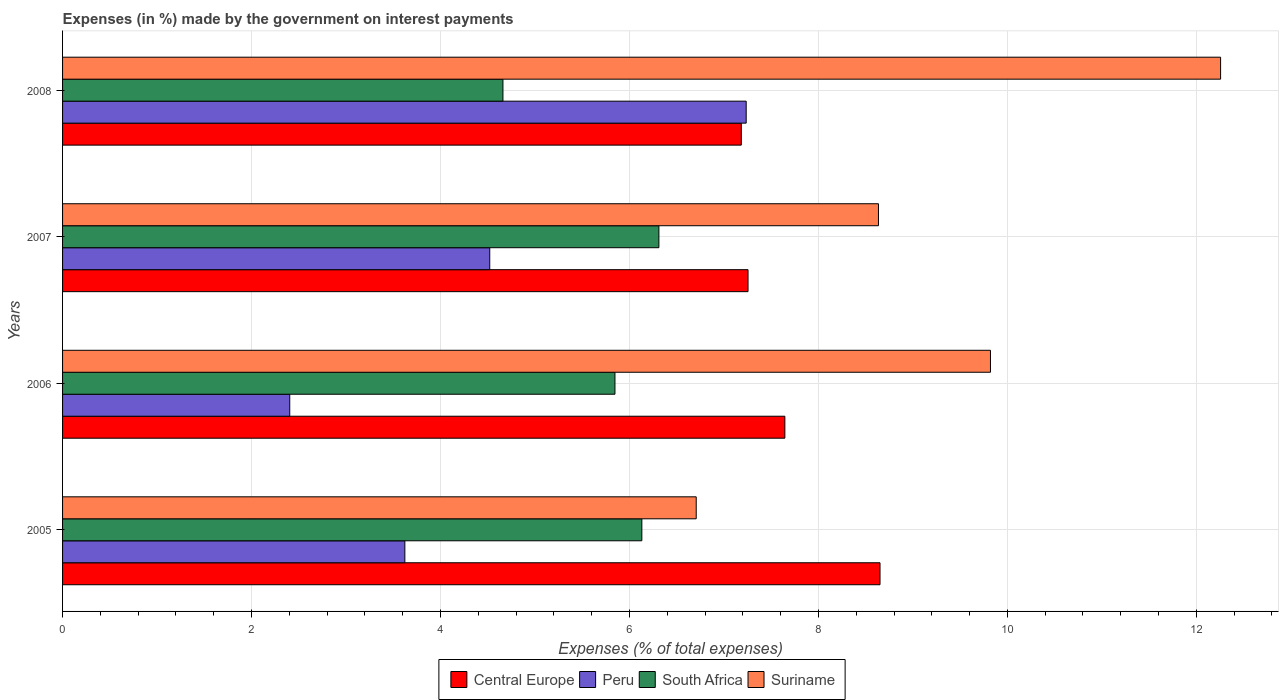How many bars are there on the 4th tick from the top?
Your answer should be compact. 4. In how many cases, is the number of bars for a given year not equal to the number of legend labels?
Your response must be concise. 0. What is the percentage of expenses made by the government on interest payments in South Africa in 2006?
Your answer should be very brief. 5.85. Across all years, what is the maximum percentage of expenses made by the government on interest payments in Central Europe?
Ensure brevity in your answer.  8.65. Across all years, what is the minimum percentage of expenses made by the government on interest payments in Peru?
Offer a terse response. 2.4. In which year was the percentage of expenses made by the government on interest payments in Peru minimum?
Ensure brevity in your answer.  2006. What is the total percentage of expenses made by the government on interest payments in Suriname in the graph?
Keep it short and to the point. 37.42. What is the difference between the percentage of expenses made by the government on interest payments in Central Europe in 2007 and that in 2008?
Ensure brevity in your answer.  0.07. What is the difference between the percentage of expenses made by the government on interest payments in Central Europe in 2008 and the percentage of expenses made by the government on interest payments in Suriname in 2007?
Offer a terse response. -1.45. What is the average percentage of expenses made by the government on interest payments in Suriname per year?
Your answer should be compact. 9.36. In the year 2007, what is the difference between the percentage of expenses made by the government on interest payments in Suriname and percentage of expenses made by the government on interest payments in South Africa?
Provide a succinct answer. 2.32. What is the ratio of the percentage of expenses made by the government on interest payments in South Africa in 2006 to that in 2008?
Your answer should be very brief. 1.25. Is the percentage of expenses made by the government on interest payments in South Africa in 2005 less than that in 2006?
Your response must be concise. No. Is the difference between the percentage of expenses made by the government on interest payments in Suriname in 2006 and 2008 greater than the difference between the percentage of expenses made by the government on interest payments in South Africa in 2006 and 2008?
Keep it short and to the point. No. What is the difference between the highest and the second highest percentage of expenses made by the government on interest payments in South Africa?
Your answer should be compact. 0.18. What is the difference between the highest and the lowest percentage of expenses made by the government on interest payments in Central Europe?
Your answer should be very brief. 1.47. Is the sum of the percentage of expenses made by the government on interest payments in Peru in 2006 and 2007 greater than the maximum percentage of expenses made by the government on interest payments in Central Europe across all years?
Offer a very short reply. No. Is it the case that in every year, the sum of the percentage of expenses made by the government on interest payments in Suriname and percentage of expenses made by the government on interest payments in South Africa is greater than the sum of percentage of expenses made by the government on interest payments in Central Europe and percentage of expenses made by the government on interest payments in Peru?
Provide a succinct answer. Yes. What does the 1st bar from the top in 2006 represents?
Your answer should be very brief. Suriname. Is it the case that in every year, the sum of the percentage of expenses made by the government on interest payments in Peru and percentage of expenses made by the government on interest payments in Suriname is greater than the percentage of expenses made by the government on interest payments in South Africa?
Your answer should be very brief. Yes. How many bars are there?
Ensure brevity in your answer.  16. What is the title of the graph?
Offer a very short reply. Expenses (in %) made by the government on interest payments. Does "San Marino" appear as one of the legend labels in the graph?
Make the answer very short. No. What is the label or title of the X-axis?
Make the answer very short. Expenses (% of total expenses). What is the label or title of the Y-axis?
Make the answer very short. Years. What is the Expenses (% of total expenses) of Central Europe in 2005?
Provide a short and direct response. 8.65. What is the Expenses (% of total expenses) of Peru in 2005?
Your response must be concise. 3.62. What is the Expenses (% of total expenses) of South Africa in 2005?
Give a very brief answer. 6.13. What is the Expenses (% of total expenses) of Suriname in 2005?
Offer a very short reply. 6.71. What is the Expenses (% of total expenses) of Central Europe in 2006?
Make the answer very short. 7.64. What is the Expenses (% of total expenses) in Peru in 2006?
Provide a short and direct response. 2.4. What is the Expenses (% of total expenses) in South Africa in 2006?
Keep it short and to the point. 5.85. What is the Expenses (% of total expenses) of Suriname in 2006?
Your response must be concise. 9.82. What is the Expenses (% of total expenses) of Central Europe in 2007?
Your answer should be compact. 7.26. What is the Expenses (% of total expenses) of Peru in 2007?
Offer a terse response. 4.52. What is the Expenses (% of total expenses) of South Africa in 2007?
Your answer should be very brief. 6.31. What is the Expenses (% of total expenses) in Suriname in 2007?
Keep it short and to the point. 8.64. What is the Expenses (% of total expenses) in Central Europe in 2008?
Give a very brief answer. 7.18. What is the Expenses (% of total expenses) in Peru in 2008?
Offer a very short reply. 7.24. What is the Expenses (% of total expenses) in South Africa in 2008?
Provide a succinct answer. 4.66. What is the Expenses (% of total expenses) of Suriname in 2008?
Keep it short and to the point. 12.26. Across all years, what is the maximum Expenses (% of total expenses) in Central Europe?
Ensure brevity in your answer.  8.65. Across all years, what is the maximum Expenses (% of total expenses) in Peru?
Offer a very short reply. 7.24. Across all years, what is the maximum Expenses (% of total expenses) of South Africa?
Provide a succinct answer. 6.31. Across all years, what is the maximum Expenses (% of total expenses) of Suriname?
Your answer should be compact. 12.26. Across all years, what is the minimum Expenses (% of total expenses) in Central Europe?
Ensure brevity in your answer.  7.18. Across all years, what is the minimum Expenses (% of total expenses) in Peru?
Provide a succinct answer. 2.4. Across all years, what is the minimum Expenses (% of total expenses) of South Africa?
Your answer should be compact. 4.66. Across all years, what is the minimum Expenses (% of total expenses) in Suriname?
Provide a succinct answer. 6.71. What is the total Expenses (% of total expenses) of Central Europe in the graph?
Provide a short and direct response. 30.74. What is the total Expenses (% of total expenses) in Peru in the graph?
Provide a succinct answer. 17.78. What is the total Expenses (% of total expenses) of South Africa in the graph?
Offer a very short reply. 22.95. What is the total Expenses (% of total expenses) in Suriname in the graph?
Provide a short and direct response. 37.42. What is the difference between the Expenses (% of total expenses) of Central Europe in 2005 and that in 2006?
Make the answer very short. 1.01. What is the difference between the Expenses (% of total expenses) of Peru in 2005 and that in 2006?
Your answer should be very brief. 1.22. What is the difference between the Expenses (% of total expenses) of South Africa in 2005 and that in 2006?
Provide a succinct answer. 0.28. What is the difference between the Expenses (% of total expenses) of Suriname in 2005 and that in 2006?
Provide a succinct answer. -3.11. What is the difference between the Expenses (% of total expenses) in Central Europe in 2005 and that in 2007?
Offer a very short reply. 1.4. What is the difference between the Expenses (% of total expenses) in Peru in 2005 and that in 2007?
Provide a succinct answer. -0.9. What is the difference between the Expenses (% of total expenses) of South Africa in 2005 and that in 2007?
Offer a terse response. -0.18. What is the difference between the Expenses (% of total expenses) of Suriname in 2005 and that in 2007?
Keep it short and to the point. -1.93. What is the difference between the Expenses (% of total expenses) in Central Europe in 2005 and that in 2008?
Offer a very short reply. 1.47. What is the difference between the Expenses (% of total expenses) in Peru in 2005 and that in 2008?
Offer a very short reply. -3.61. What is the difference between the Expenses (% of total expenses) in South Africa in 2005 and that in 2008?
Keep it short and to the point. 1.47. What is the difference between the Expenses (% of total expenses) in Suriname in 2005 and that in 2008?
Make the answer very short. -5.55. What is the difference between the Expenses (% of total expenses) of Central Europe in 2006 and that in 2007?
Ensure brevity in your answer.  0.39. What is the difference between the Expenses (% of total expenses) in Peru in 2006 and that in 2007?
Your answer should be compact. -2.12. What is the difference between the Expenses (% of total expenses) in South Africa in 2006 and that in 2007?
Ensure brevity in your answer.  -0.47. What is the difference between the Expenses (% of total expenses) in Suriname in 2006 and that in 2007?
Ensure brevity in your answer.  1.19. What is the difference between the Expenses (% of total expenses) of Central Europe in 2006 and that in 2008?
Keep it short and to the point. 0.46. What is the difference between the Expenses (% of total expenses) in Peru in 2006 and that in 2008?
Make the answer very short. -4.83. What is the difference between the Expenses (% of total expenses) in South Africa in 2006 and that in 2008?
Provide a succinct answer. 1.19. What is the difference between the Expenses (% of total expenses) of Suriname in 2006 and that in 2008?
Your answer should be compact. -2.44. What is the difference between the Expenses (% of total expenses) of Central Europe in 2007 and that in 2008?
Provide a succinct answer. 0.07. What is the difference between the Expenses (% of total expenses) in Peru in 2007 and that in 2008?
Make the answer very short. -2.71. What is the difference between the Expenses (% of total expenses) of South Africa in 2007 and that in 2008?
Your response must be concise. 1.65. What is the difference between the Expenses (% of total expenses) in Suriname in 2007 and that in 2008?
Provide a succinct answer. -3.62. What is the difference between the Expenses (% of total expenses) of Central Europe in 2005 and the Expenses (% of total expenses) of Peru in 2006?
Offer a very short reply. 6.25. What is the difference between the Expenses (% of total expenses) of Central Europe in 2005 and the Expenses (% of total expenses) of South Africa in 2006?
Make the answer very short. 2.81. What is the difference between the Expenses (% of total expenses) in Central Europe in 2005 and the Expenses (% of total expenses) in Suriname in 2006?
Give a very brief answer. -1.17. What is the difference between the Expenses (% of total expenses) of Peru in 2005 and the Expenses (% of total expenses) of South Africa in 2006?
Provide a succinct answer. -2.22. What is the difference between the Expenses (% of total expenses) in Peru in 2005 and the Expenses (% of total expenses) in Suriname in 2006?
Your answer should be very brief. -6.2. What is the difference between the Expenses (% of total expenses) of South Africa in 2005 and the Expenses (% of total expenses) of Suriname in 2006?
Your response must be concise. -3.69. What is the difference between the Expenses (% of total expenses) in Central Europe in 2005 and the Expenses (% of total expenses) in Peru in 2007?
Provide a succinct answer. 4.13. What is the difference between the Expenses (% of total expenses) in Central Europe in 2005 and the Expenses (% of total expenses) in South Africa in 2007?
Give a very brief answer. 2.34. What is the difference between the Expenses (% of total expenses) in Central Europe in 2005 and the Expenses (% of total expenses) in Suriname in 2007?
Provide a succinct answer. 0.02. What is the difference between the Expenses (% of total expenses) of Peru in 2005 and the Expenses (% of total expenses) of South Africa in 2007?
Ensure brevity in your answer.  -2.69. What is the difference between the Expenses (% of total expenses) in Peru in 2005 and the Expenses (% of total expenses) in Suriname in 2007?
Provide a short and direct response. -5.01. What is the difference between the Expenses (% of total expenses) of South Africa in 2005 and the Expenses (% of total expenses) of Suriname in 2007?
Provide a succinct answer. -2.5. What is the difference between the Expenses (% of total expenses) in Central Europe in 2005 and the Expenses (% of total expenses) in Peru in 2008?
Provide a short and direct response. 1.42. What is the difference between the Expenses (% of total expenses) in Central Europe in 2005 and the Expenses (% of total expenses) in South Africa in 2008?
Make the answer very short. 3.99. What is the difference between the Expenses (% of total expenses) in Central Europe in 2005 and the Expenses (% of total expenses) in Suriname in 2008?
Keep it short and to the point. -3.6. What is the difference between the Expenses (% of total expenses) in Peru in 2005 and the Expenses (% of total expenses) in South Africa in 2008?
Offer a very short reply. -1.04. What is the difference between the Expenses (% of total expenses) of Peru in 2005 and the Expenses (% of total expenses) of Suriname in 2008?
Your answer should be very brief. -8.63. What is the difference between the Expenses (% of total expenses) of South Africa in 2005 and the Expenses (% of total expenses) of Suriname in 2008?
Provide a short and direct response. -6.13. What is the difference between the Expenses (% of total expenses) in Central Europe in 2006 and the Expenses (% of total expenses) in Peru in 2007?
Offer a very short reply. 3.12. What is the difference between the Expenses (% of total expenses) in Central Europe in 2006 and the Expenses (% of total expenses) in South Africa in 2007?
Ensure brevity in your answer.  1.33. What is the difference between the Expenses (% of total expenses) in Central Europe in 2006 and the Expenses (% of total expenses) in Suriname in 2007?
Ensure brevity in your answer.  -0.99. What is the difference between the Expenses (% of total expenses) of Peru in 2006 and the Expenses (% of total expenses) of South Africa in 2007?
Offer a very short reply. -3.91. What is the difference between the Expenses (% of total expenses) of Peru in 2006 and the Expenses (% of total expenses) of Suriname in 2007?
Offer a terse response. -6.23. What is the difference between the Expenses (% of total expenses) in South Africa in 2006 and the Expenses (% of total expenses) in Suriname in 2007?
Your response must be concise. -2.79. What is the difference between the Expenses (% of total expenses) in Central Europe in 2006 and the Expenses (% of total expenses) in Peru in 2008?
Offer a terse response. 0.41. What is the difference between the Expenses (% of total expenses) of Central Europe in 2006 and the Expenses (% of total expenses) of South Africa in 2008?
Make the answer very short. 2.98. What is the difference between the Expenses (% of total expenses) of Central Europe in 2006 and the Expenses (% of total expenses) of Suriname in 2008?
Provide a short and direct response. -4.61. What is the difference between the Expenses (% of total expenses) in Peru in 2006 and the Expenses (% of total expenses) in South Africa in 2008?
Offer a very short reply. -2.26. What is the difference between the Expenses (% of total expenses) in Peru in 2006 and the Expenses (% of total expenses) in Suriname in 2008?
Provide a succinct answer. -9.85. What is the difference between the Expenses (% of total expenses) in South Africa in 2006 and the Expenses (% of total expenses) in Suriname in 2008?
Your response must be concise. -6.41. What is the difference between the Expenses (% of total expenses) in Central Europe in 2007 and the Expenses (% of total expenses) in Peru in 2008?
Make the answer very short. 0.02. What is the difference between the Expenses (% of total expenses) in Central Europe in 2007 and the Expenses (% of total expenses) in South Africa in 2008?
Offer a terse response. 2.59. What is the difference between the Expenses (% of total expenses) in Central Europe in 2007 and the Expenses (% of total expenses) in Suriname in 2008?
Your response must be concise. -5. What is the difference between the Expenses (% of total expenses) in Peru in 2007 and the Expenses (% of total expenses) in South Africa in 2008?
Provide a short and direct response. -0.14. What is the difference between the Expenses (% of total expenses) in Peru in 2007 and the Expenses (% of total expenses) in Suriname in 2008?
Your response must be concise. -7.74. What is the difference between the Expenses (% of total expenses) in South Africa in 2007 and the Expenses (% of total expenses) in Suriname in 2008?
Keep it short and to the point. -5.95. What is the average Expenses (% of total expenses) in Central Europe per year?
Make the answer very short. 7.68. What is the average Expenses (% of total expenses) of Peru per year?
Keep it short and to the point. 4.45. What is the average Expenses (% of total expenses) in South Africa per year?
Keep it short and to the point. 5.74. What is the average Expenses (% of total expenses) in Suriname per year?
Offer a very short reply. 9.36. In the year 2005, what is the difference between the Expenses (% of total expenses) in Central Europe and Expenses (% of total expenses) in Peru?
Offer a very short reply. 5.03. In the year 2005, what is the difference between the Expenses (% of total expenses) in Central Europe and Expenses (% of total expenses) in South Africa?
Offer a very short reply. 2.52. In the year 2005, what is the difference between the Expenses (% of total expenses) in Central Europe and Expenses (% of total expenses) in Suriname?
Provide a short and direct response. 1.95. In the year 2005, what is the difference between the Expenses (% of total expenses) in Peru and Expenses (% of total expenses) in South Africa?
Make the answer very short. -2.51. In the year 2005, what is the difference between the Expenses (% of total expenses) of Peru and Expenses (% of total expenses) of Suriname?
Give a very brief answer. -3.08. In the year 2005, what is the difference between the Expenses (% of total expenses) of South Africa and Expenses (% of total expenses) of Suriname?
Your answer should be very brief. -0.58. In the year 2006, what is the difference between the Expenses (% of total expenses) of Central Europe and Expenses (% of total expenses) of Peru?
Make the answer very short. 5.24. In the year 2006, what is the difference between the Expenses (% of total expenses) in Central Europe and Expenses (% of total expenses) in South Africa?
Your answer should be compact. 1.8. In the year 2006, what is the difference between the Expenses (% of total expenses) of Central Europe and Expenses (% of total expenses) of Suriname?
Keep it short and to the point. -2.18. In the year 2006, what is the difference between the Expenses (% of total expenses) of Peru and Expenses (% of total expenses) of South Africa?
Provide a succinct answer. -3.44. In the year 2006, what is the difference between the Expenses (% of total expenses) in Peru and Expenses (% of total expenses) in Suriname?
Your response must be concise. -7.42. In the year 2006, what is the difference between the Expenses (% of total expenses) in South Africa and Expenses (% of total expenses) in Suriname?
Your answer should be very brief. -3.97. In the year 2007, what is the difference between the Expenses (% of total expenses) of Central Europe and Expenses (% of total expenses) of Peru?
Provide a short and direct response. 2.73. In the year 2007, what is the difference between the Expenses (% of total expenses) in Central Europe and Expenses (% of total expenses) in South Africa?
Your answer should be compact. 0.94. In the year 2007, what is the difference between the Expenses (% of total expenses) in Central Europe and Expenses (% of total expenses) in Suriname?
Give a very brief answer. -1.38. In the year 2007, what is the difference between the Expenses (% of total expenses) in Peru and Expenses (% of total expenses) in South Africa?
Your response must be concise. -1.79. In the year 2007, what is the difference between the Expenses (% of total expenses) of Peru and Expenses (% of total expenses) of Suriname?
Provide a short and direct response. -4.11. In the year 2007, what is the difference between the Expenses (% of total expenses) of South Africa and Expenses (% of total expenses) of Suriname?
Your response must be concise. -2.32. In the year 2008, what is the difference between the Expenses (% of total expenses) in Central Europe and Expenses (% of total expenses) in Peru?
Provide a short and direct response. -0.05. In the year 2008, what is the difference between the Expenses (% of total expenses) of Central Europe and Expenses (% of total expenses) of South Africa?
Offer a terse response. 2.52. In the year 2008, what is the difference between the Expenses (% of total expenses) in Central Europe and Expenses (% of total expenses) in Suriname?
Your answer should be compact. -5.07. In the year 2008, what is the difference between the Expenses (% of total expenses) in Peru and Expenses (% of total expenses) in South Africa?
Give a very brief answer. 2.57. In the year 2008, what is the difference between the Expenses (% of total expenses) of Peru and Expenses (% of total expenses) of Suriname?
Keep it short and to the point. -5.02. In the year 2008, what is the difference between the Expenses (% of total expenses) in South Africa and Expenses (% of total expenses) in Suriname?
Provide a short and direct response. -7.6. What is the ratio of the Expenses (% of total expenses) in Central Europe in 2005 to that in 2006?
Give a very brief answer. 1.13. What is the ratio of the Expenses (% of total expenses) of Peru in 2005 to that in 2006?
Your answer should be compact. 1.51. What is the ratio of the Expenses (% of total expenses) of South Africa in 2005 to that in 2006?
Make the answer very short. 1.05. What is the ratio of the Expenses (% of total expenses) of Suriname in 2005 to that in 2006?
Provide a short and direct response. 0.68. What is the ratio of the Expenses (% of total expenses) in Central Europe in 2005 to that in 2007?
Keep it short and to the point. 1.19. What is the ratio of the Expenses (% of total expenses) of Peru in 2005 to that in 2007?
Your response must be concise. 0.8. What is the ratio of the Expenses (% of total expenses) of South Africa in 2005 to that in 2007?
Your response must be concise. 0.97. What is the ratio of the Expenses (% of total expenses) in Suriname in 2005 to that in 2007?
Give a very brief answer. 0.78. What is the ratio of the Expenses (% of total expenses) of Central Europe in 2005 to that in 2008?
Offer a very short reply. 1.2. What is the ratio of the Expenses (% of total expenses) of Peru in 2005 to that in 2008?
Your answer should be very brief. 0.5. What is the ratio of the Expenses (% of total expenses) in South Africa in 2005 to that in 2008?
Offer a very short reply. 1.32. What is the ratio of the Expenses (% of total expenses) of Suriname in 2005 to that in 2008?
Ensure brevity in your answer.  0.55. What is the ratio of the Expenses (% of total expenses) in Central Europe in 2006 to that in 2007?
Offer a very short reply. 1.05. What is the ratio of the Expenses (% of total expenses) of Peru in 2006 to that in 2007?
Provide a succinct answer. 0.53. What is the ratio of the Expenses (% of total expenses) of South Africa in 2006 to that in 2007?
Your response must be concise. 0.93. What is the ratio of the Expenses (% of total expenses) in Suriname in 2006 to that in 2007?
Your answer should be very brief. 1.14. What is the ratio of the Expenses (% of total expenses) in Central Europe in 2006 to that in 2008?
Your answer should be very brief. 1.06. What is the ratio of the Expenses (% of total expenses) of Peru in 2006 to that in 2008?
Provide a short and direct response. 0.33. What is the ratio of the Expenses (% of total expenses) of South Africa in 2006 to that in 2008?
Keep it short and to the point. 1.25. What is the ratio of the Expenses (% of total expenses) of Suriname in 2006 to that in 2008?
Offer a very short reply. 0.8. What is the ratio of the Expenses (% of total expenses) of Central Europe in 2007 to that in 2008?
Offer a terse response. 1.01. What is the ratio of the Expenses (% of total expenses) of Peru in 2007 to that in 2008?
Your answer should be compact. 0.62. What is the ratio of the Expenses (% of total expenses) of South Africa in 2007 to that in 2008?
Provide a short and direct response. 1.35. What is the ratio of the Expenses (% of total expenses) in Suriname in 2007 to that in 2008?
Give a very brief answer. 0.7. What is the difference between the highest and the second highest Expenses (% of total expenses) of Central Europe?
Provide a succinct answer. 1.01. What is the difference between the highest and the second highest Expenses (% of total expenses) in Peru?
Keep it short and to the point. 2.71. What is the difference between the highest and the second highest Expenses (% of total expenses) of South Africa?
Offer a terse response. 0.18. What is the difference between the highest and the second highest Expenses (% of total expenses) in Suriname?
Give a very brief answer. 2.44. What is the difference between the highest and the lowest Expenses (% of total expenses) in Central Europe?
Provide a short and direct response. 1.47. What is the difference between the highest and the lowest Expenses (% of total expenses) in Peru?
Offer a very short reply. 4.83. What is the difference between the highest and the lowest Expenses (% of total expenses) of South Africa?
Your answer should be compact. 1.65. What is the difference between the highest and the lowest Expenses (% of total expenses) in Suriname?
Make the answer very short. 5.55. 